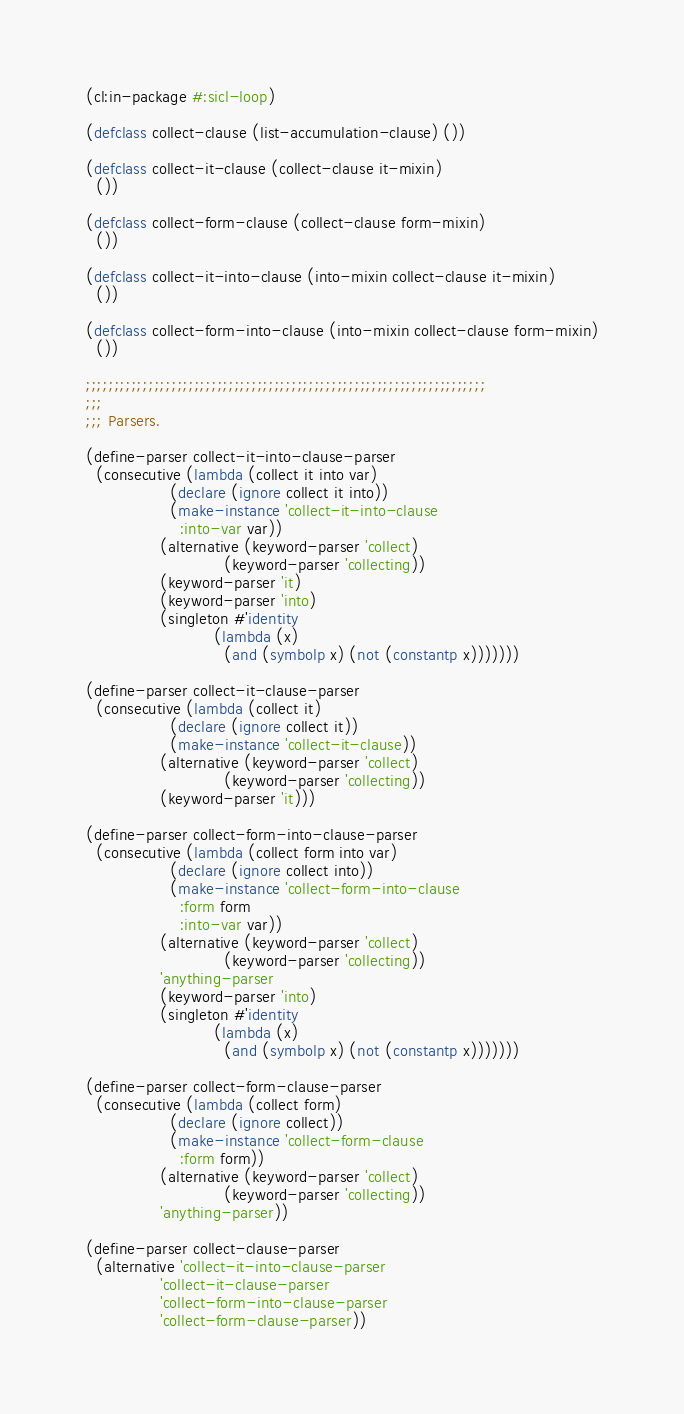Convert code to text. <code><loc_0><loc_0><loc_500><loc_500><_Lisp_>(cl:in-package #:sicl-loop)

(defclass collect-clause (list-accumulation-clause) ())

(defclass collect-it-clause (collect-clause it-mixin)
  ())

(defclass collect-form-clause (collect-clause form-mixin)
  ())

(defclass collect-it-into-clause (into-mixin collect-clause it-mixin)
  ())

(defclass collect-form-into-clause (into-mixin collect-clause form-mixin)
  ())

;;;;;;;;;;;;;;;;;;;;;;;;;;;;;;;;;;;;;;;;;;;;;;;;;;;;;;;;;;;;;;;;;;;;;;
;;;
;;; Parsers.

(define-parser collect-it-into-clause-parser
  (consecutive (lambda (collect it into var)
                 (declare (ignore collect it into))
                 (make-instance 'collect-it-into-clause
                   :into-var var))
               (alternative (keyword-parser 'collect)
                            (keyword-parser 'collecting))
               (keyword-parser 'it)
               (keyword-parser 'into)
               (singleton #'identity
                          (lambda (x)
                            (and (symbolp x) (not (constantp x)))))))

(define-parser collect-it-clause-parser
  (consecutive (lambda (collect it)
                 (declare (ignore collect it))
                 (make-instance 'collect-it-clause))
               (alternative (keyword-parser 'collect)
                            (keyword-parser 'collecting))
               (keyword-parser 'it)))

(define-parser collect-form-into-clause-parser
  (consecutive (lambda (collect form into var)
                 (declare (ignore collect into))
                 (make-instance 'collect-form-into-clause
                   :form form
                   :into-var var))
               (alternative (keyword-parser 'collect)
                            (keyword-parser 'collecting))
               'anything-parser
               (keyword-parser 'into)
               (singleton #'identity
                          (lambda (x)
                            (and (symbolp x) (not (constantp x)))))))

(define-parser collect-form-clause-parser
  (consecutive (lambda (collect form)
                 (declare (ignore collect))
                 (make-instance 'collect-form-clause
                   :form form))
               (alternative (keyword-parser 'collect)
                            (keyword-parser 'collecting))
               'anything-parser))

(define-parser collect-clause-parser
  (alternative 'collect-it-into-clause-parser
               'collect-it-clause-parser
               'collect-form-into-clause-parser
               'collect-form-clause-parser))
</code> 